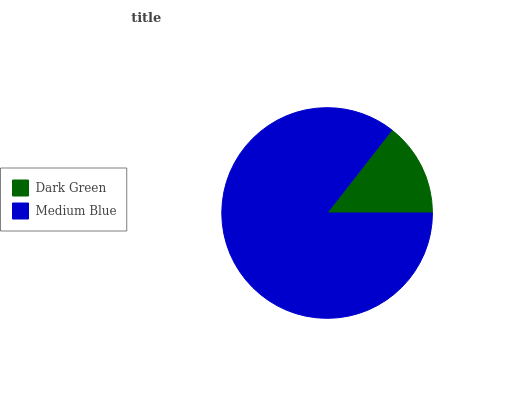Is Dark Green the minimum?
Answer yes or no. Yes. Is Medium Blue the maximum?
Answer yes or no. Yes. Is Medium Blue the minimum?
Answer yes or no. No. Is Medium Blue greater than Dark Green?
Answer yes or no. Yes. Is Dark Green less than Medium Blue?
Answer yes or no. Yes. Is Dark Green greater than Medium Blue?
Answer yes or no. No. Is Medium Blue less than Dark Green?
Answer yes or no. No. Is Medium Blue the high median?
Answer yes or no. Yes. Is Dark Green the low median?
Answer yes or no. Yes. Is Dark Green the high median?
Answer yes or no. No. Is Medium Blue the low median?
Answer yes or no. No. 